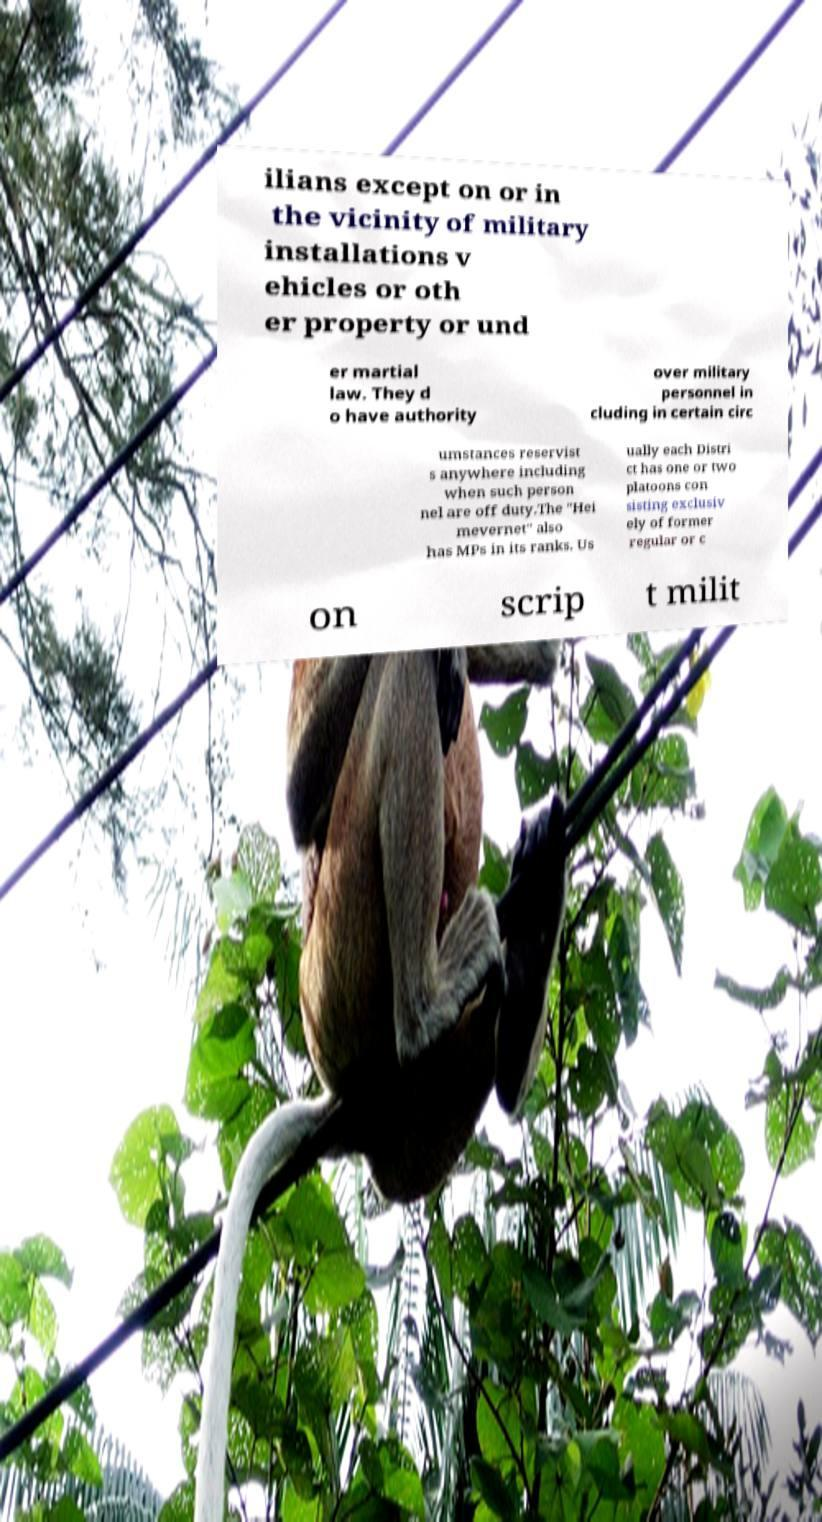For documentation purposes, I need the text within this image transcribed. Could you provide that? ilians except on or in the vicinity of military installations v ehicles or oth er property or und er martial law. They d o have authority over military personnel in cluding in certain circ umstances reservist s anywhere including when such person nel are off duty.The "Hei mevernet" also has MPs in its ranks. Us ually each Distri ct has one or two platoons con sisting exclusiv ely of former regular or c on scrip t milit 